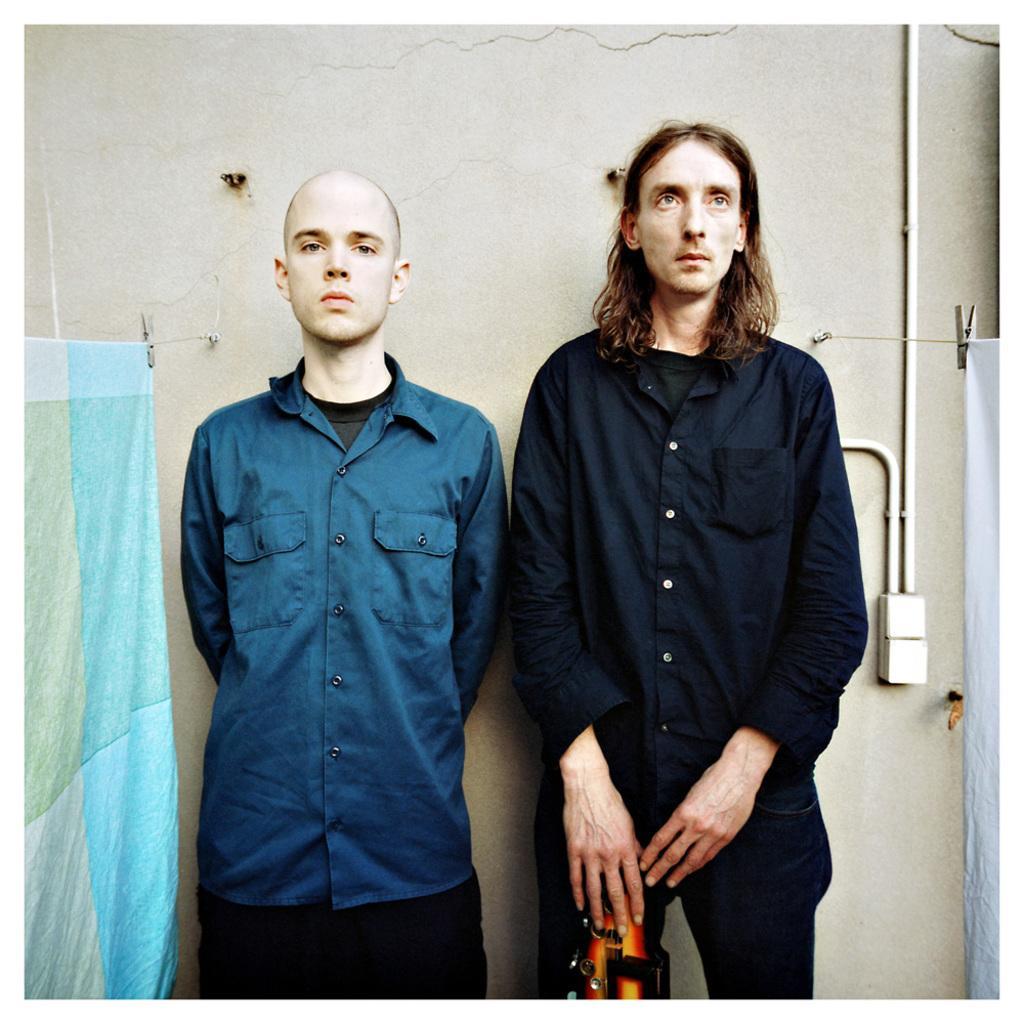In one or two sentences, can you explain what this image depicts? Here we can see two men standing and beside them we can see blankets present 